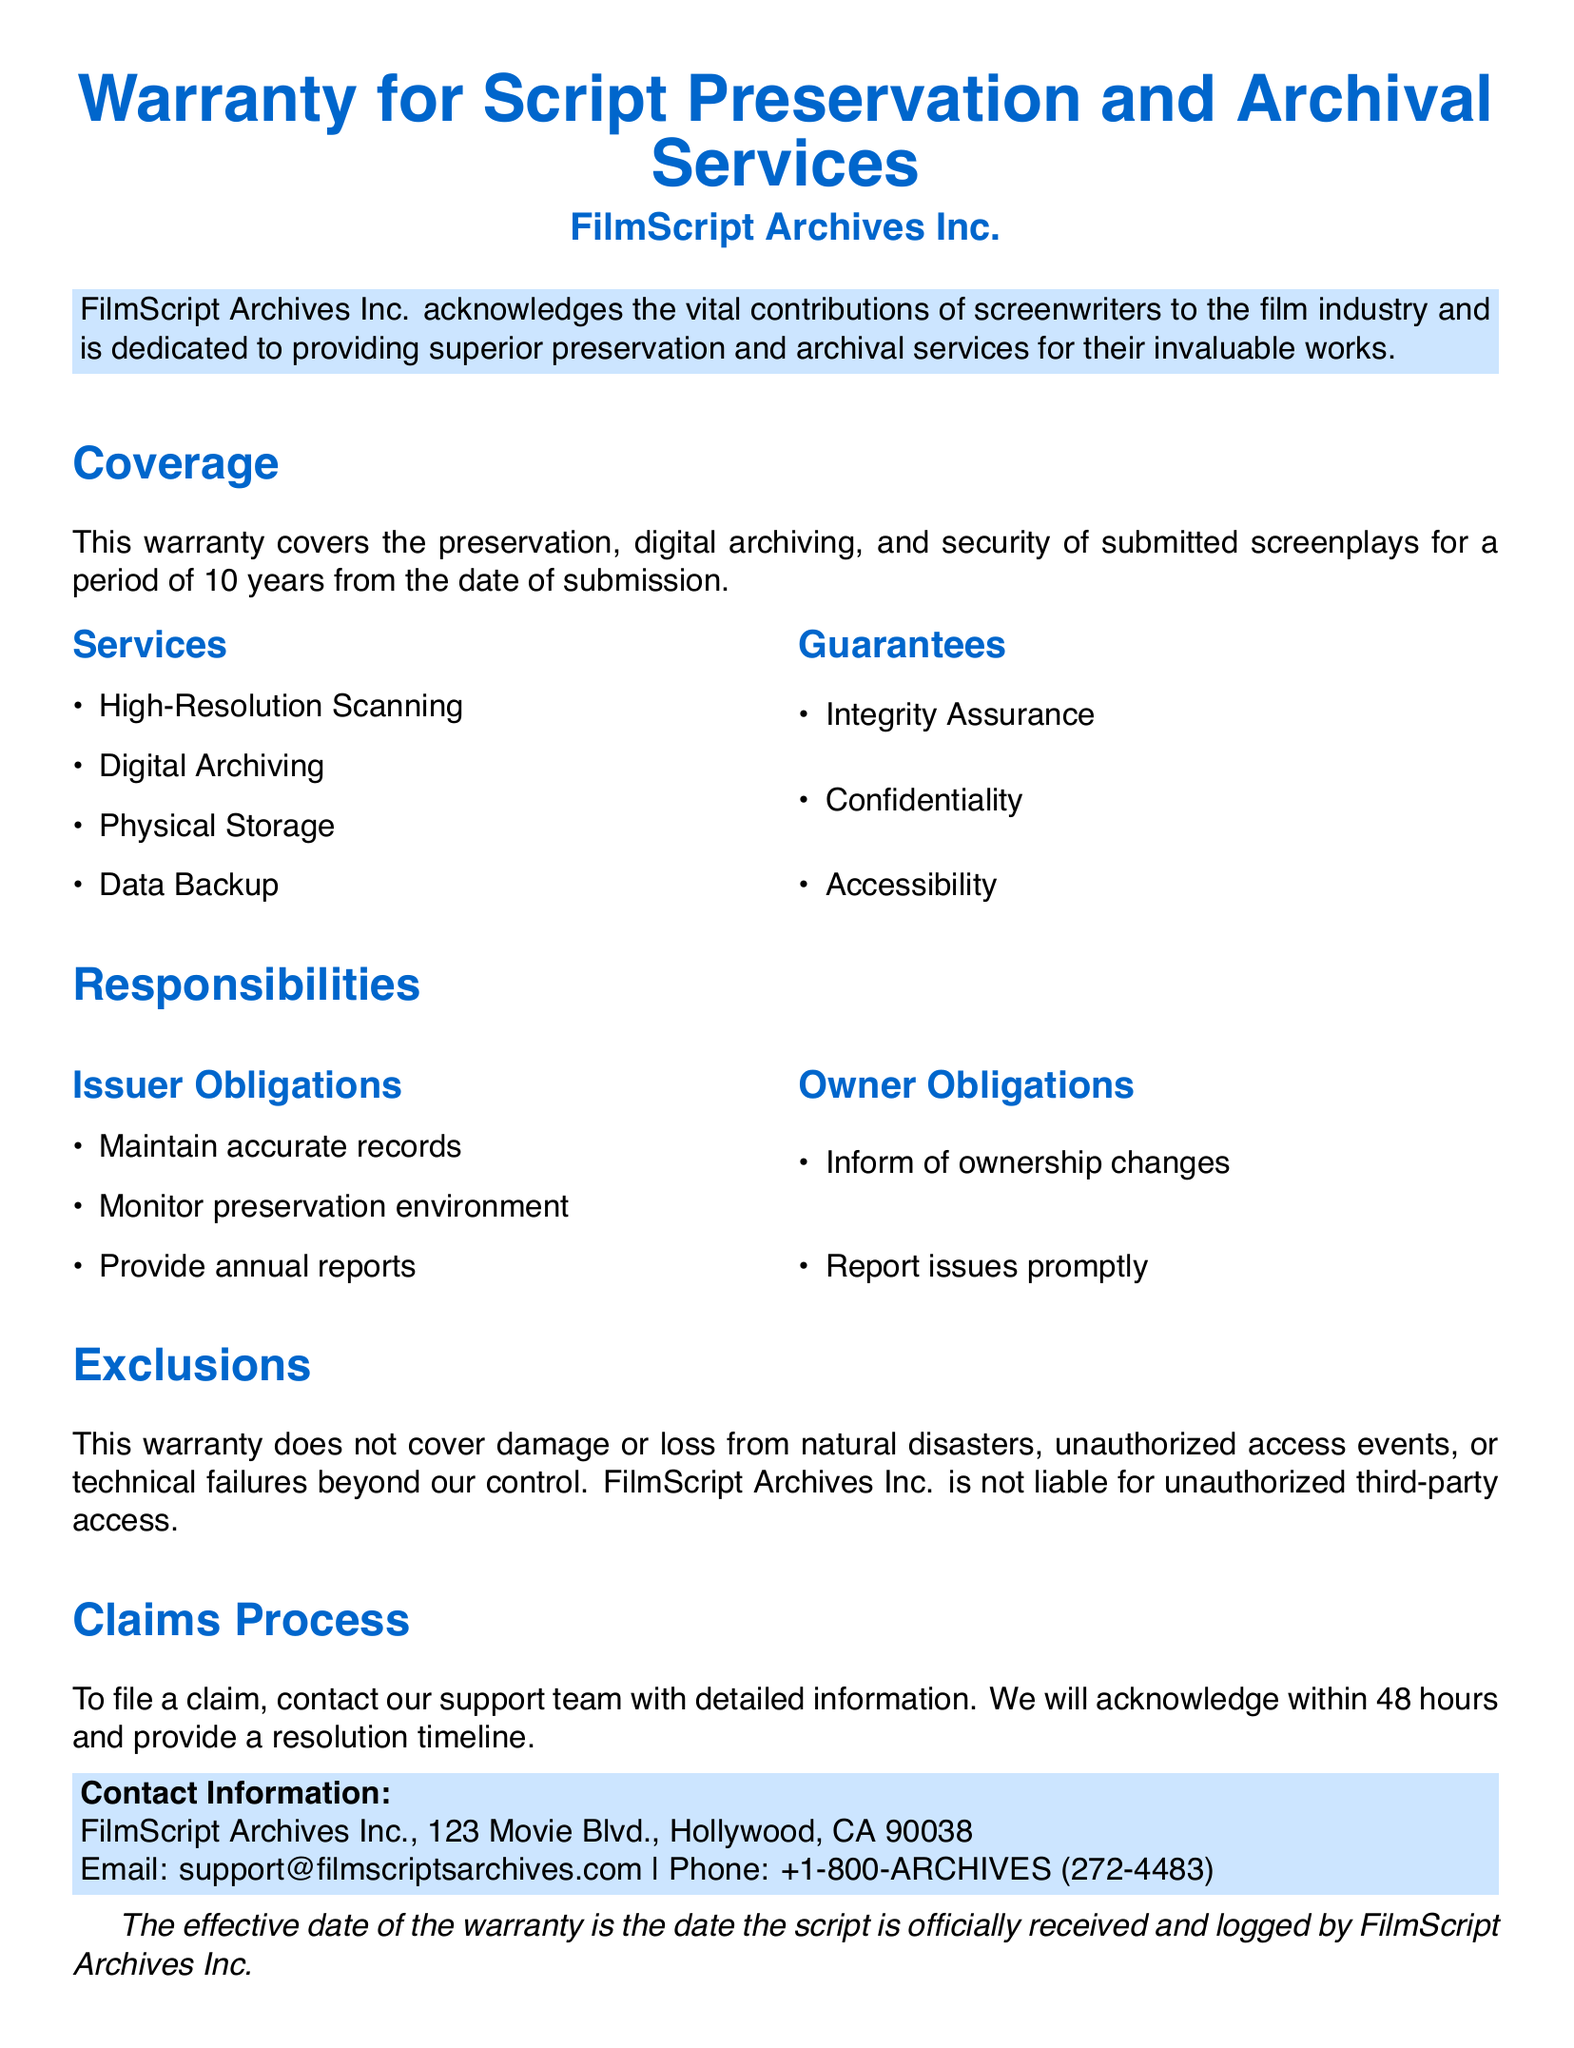What is the duration of the warranty? The warranty covers a period of 10 years from the date of submission.
Answer: 10 years What services are included in the warranty? The document lists several services provided, including High-Resolution Scanning, Digital Archiving, Physical Storage, and Data Backup.
Answer: High-Resolution Scanning, Digital Archiving, Physical Storage, Data Backup What type of assurances does the warranty provide? The document specifies guarantees such as Integrity Assurance, Confidentiality, and Accessibility.
Answer: Integrity Assurance, Confidentiality, Accessibility What must the Owner do if ownership changes? The Owner must inform FilmScript Archives Inc. of any changes in ownership.
Answer: Inform of ownership changes What is the effective date of the warranty? The effective date is the date the script is officially received and logged by FilmScript Archives Inc.
Answer: Date the script is officially received and logged What are the responsibilities of FilmScript Archives Inc.? The issuer's obligations include maintaining accurate records, monitoring the preservation environment, and providing annual reports.
Answer: Maintain accurate records, monitor preservation environment, provide annual reports What types of events are excluded from the warranty? The warranty does not cover damage or loss from natural disasters, unauthorized access events, or technical failures beyond control.
Answer: Natural disasters, unauthorized access events, technical failures How quickly will claims be acknowledged? Claims will be acknowledged within 48 hours of being submitted to the support team.
Answer: Within 48 hours What is the contact email for FilmScript Archives Inc.? The document provides an email address for contacting support.
Answer: support@filmscriptsarchives.com 